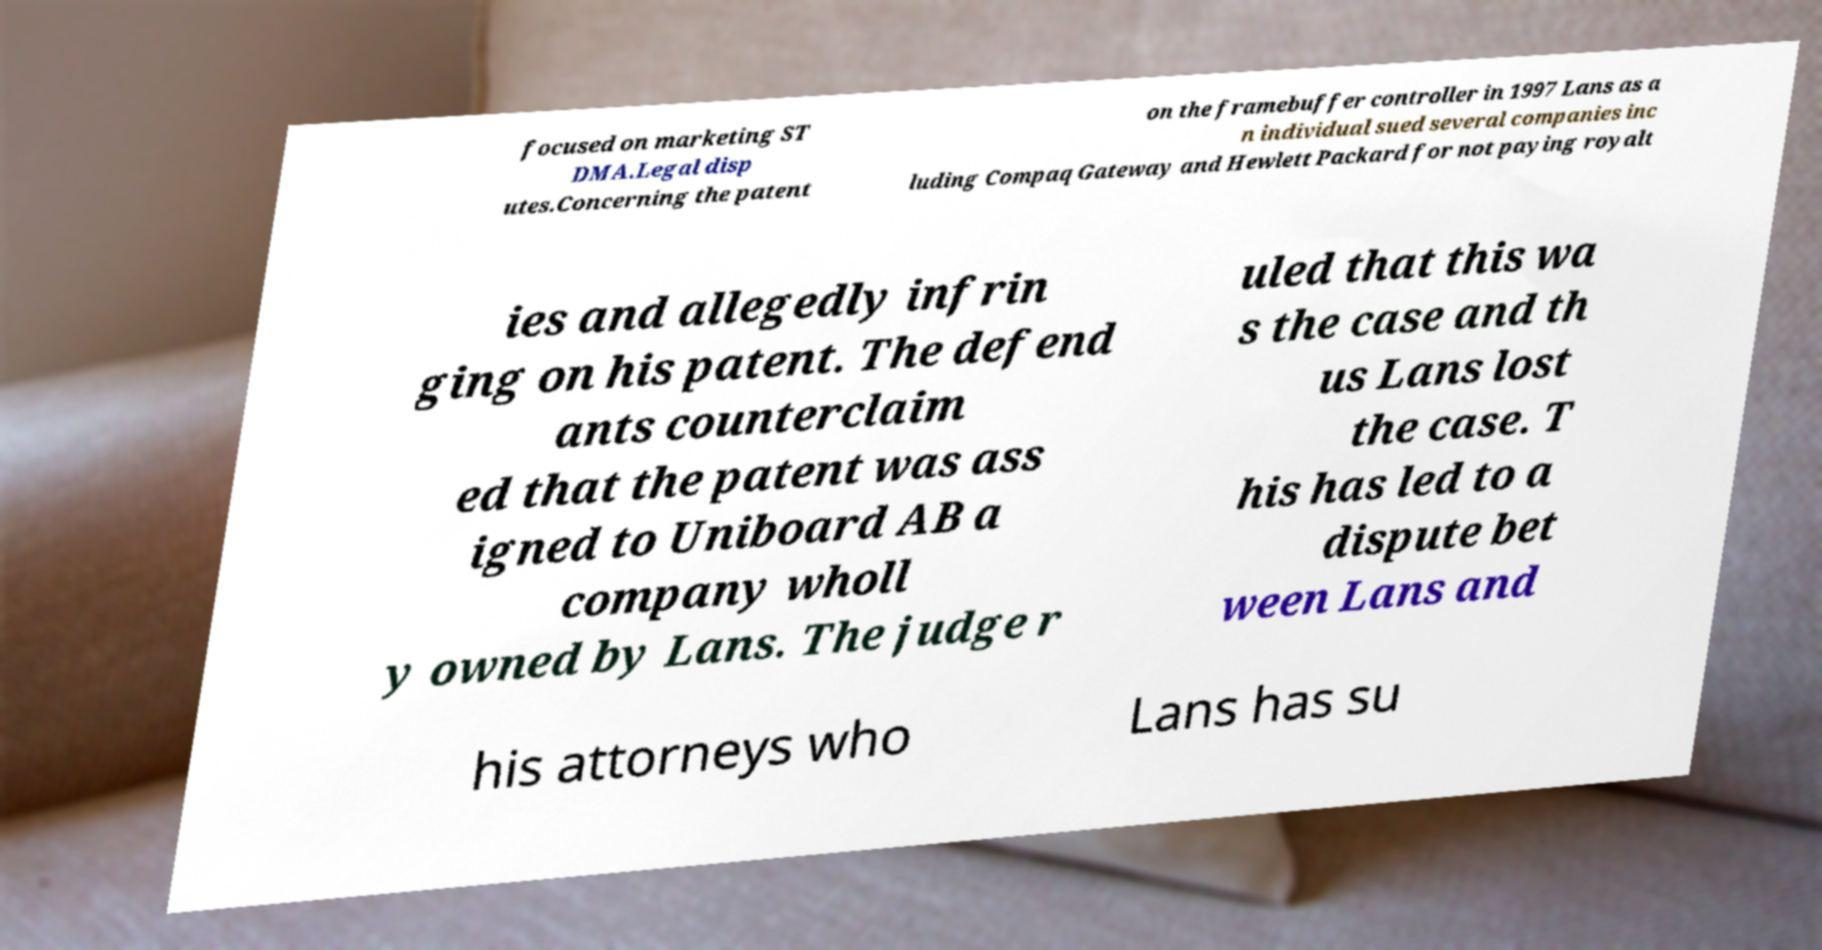Could you assist in decoding the text presented in this image and type it out clearly? focused on marketing ST DMA.Legal disp utes.Concerning the patent on the framebuffer controller in 1997 Lans as a n individual sued several companies inc luding Compaq Gateway and Hewlett Packard for not paying royalt ies and allegedly infrin ging on his patent. The defend ants counterclaim ed that the patent was ass igned to Uniboard AB a company wholl y owned by Lans. The judge r uled that this wa s the case and th us Lans lost the case. T his has led to a dispute bet ween Lans and his attorneys who Lans has su 